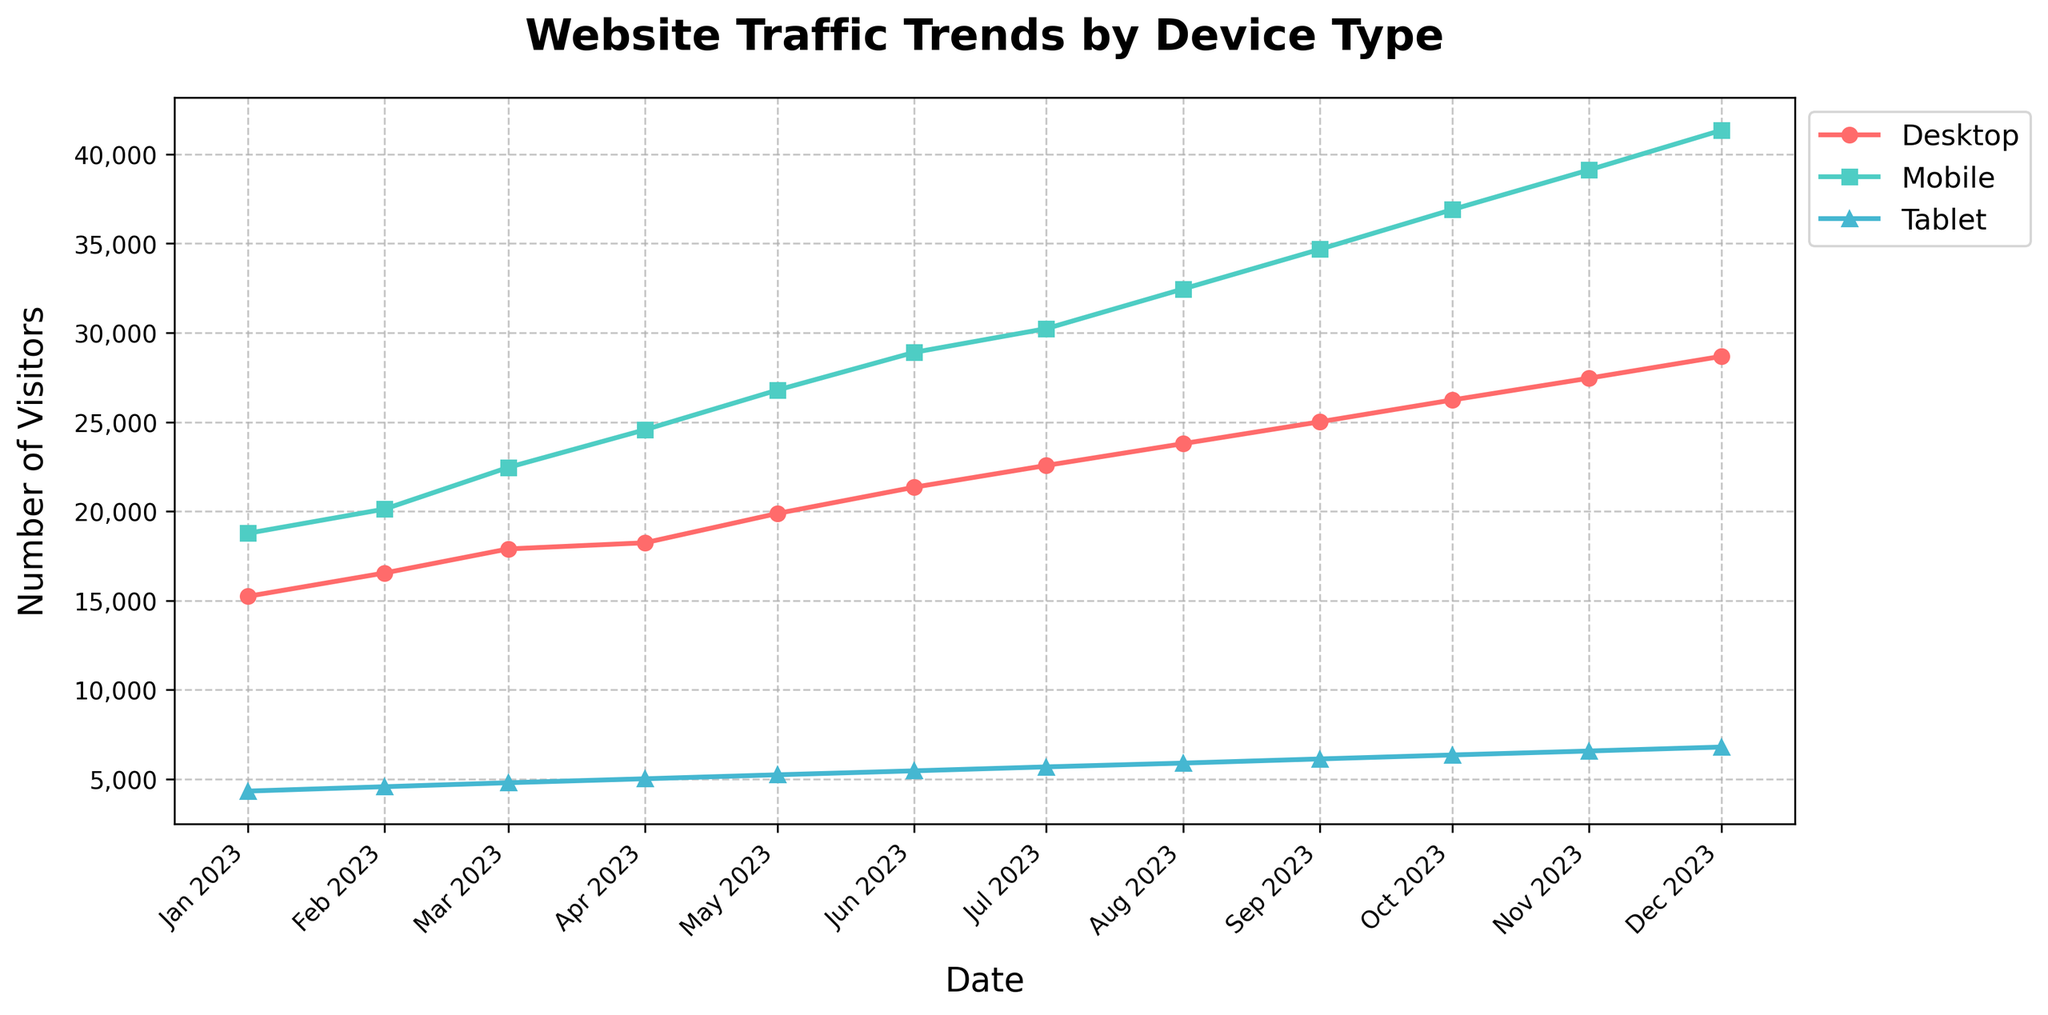What's the overall trend for the number of visitors from Mobile devices over time? The plot shows an upward trend for Mobile devices. The monthly visitor count increases consistently from January to December. Starting at 18,765 visitors in January, it grows to 41,345 visitors by December.
Answer: Increasing Which device type had the highest number of visitors in December 2023? By analyzing the plot, Mobile devices had the highest number of visitors in December 2023 with 41,345 visitors, surpassing Desktop and Tablet visits.
Answer: Mobile In which month did the number of Desktop visitors first exceed 20,000? Observing the Desktop line, the number of visitors first exceeded 20,000 in June 2023, when it reached 21,345 visitors.
Answer: June 2023 What's the difference in the number of Mobile visitors between January and December 2023? The number of Mobile visitors in January is 18,765 and in December is 41,345. The difference is calculated as 41,345 - 18,765 = 22,580.
Answer: 22,580 Among Desktop, Mobile, and Tablet, which device type had the highest growth rate in visitor numbers from January to December 2023? By looking at the slopes of the lines, the Mobile device showed the steepest increase from 18,765 to 41,345, compared to Desktop (15,234 to 28,678) and Tablet (4,321 to 6,789). This indicates Mobile had the highest growth rate.
Answer: Mobile What is the combined number of visitors for all device types in July 2023? Summing up the visitors for Desktop (22,567), Mobile (30,234), and Tablet (5,678) in July 2023, we get a total of 22,567 + 30,234 + 5,678 = 58,479 visitors.
Answer: 58,479 In which months did the number of Tablet visitors surpass 5,000? Checking the Tablet line, the number of visitors first surpassed 5,000 in April 2023 and maintained that level through December 2023.
Answer: April to December Is there any month where the number of Desktop visitors and Mobile visitors are approximately equal? By comparing the lines visually, there is no month where the number of Desktop visitors is approximately equal to the number of Mobile visitors; Mobile consistently has a higher visitor count.
Answer: No What is the average number of visitors for the Tablet across the year 2023? To find the average, sum the visitors from all months and divide by 12: (4,321 + 4,567 + 4,789 + 5,012 + 5,234 + 5,456 + 5,678 + 5,890 + 6,123 + 6,345 + 6,567 + 6,789) / 12 = 5,481.67.
Answer: 5,482 